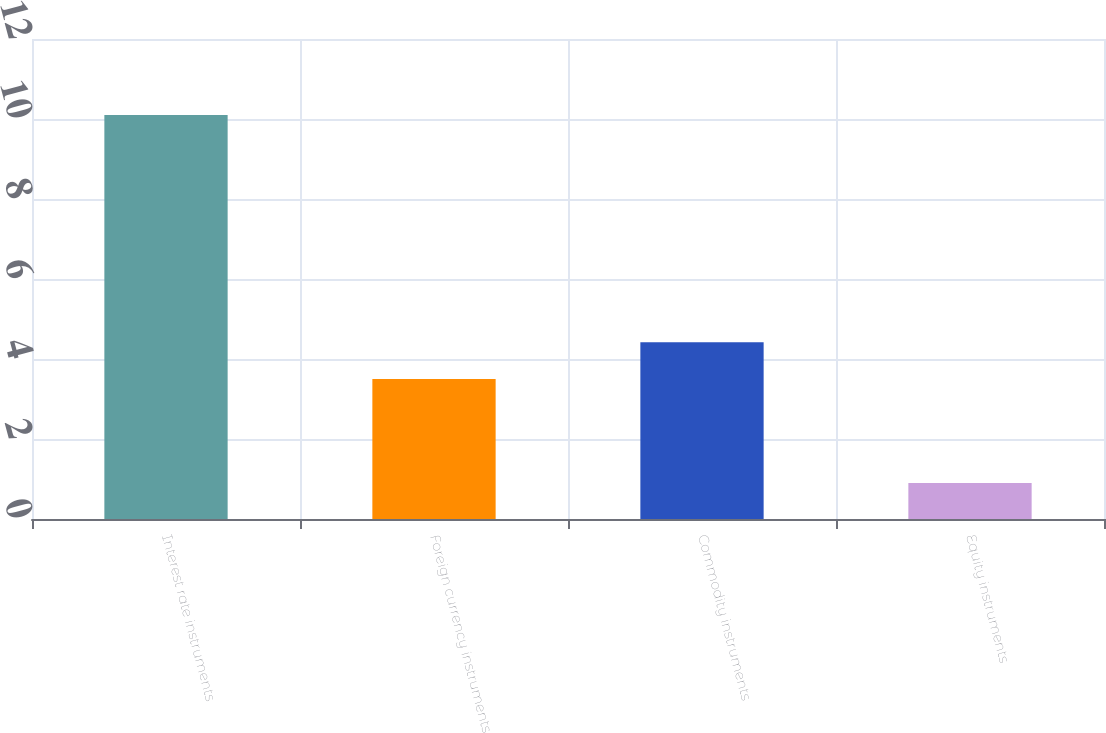Convert chart. <chart><loc_0><loc_0><loc_500><loc_500><bar_chart><fcel>Interest rate instruments<fcel>Foreign currency instruments<fcel>Commodity instruments<fcel>Equity instruments<nl><fcel>10.1<fcel>3.5<fcel>4.42<fcel>0.9<nl></chart> 